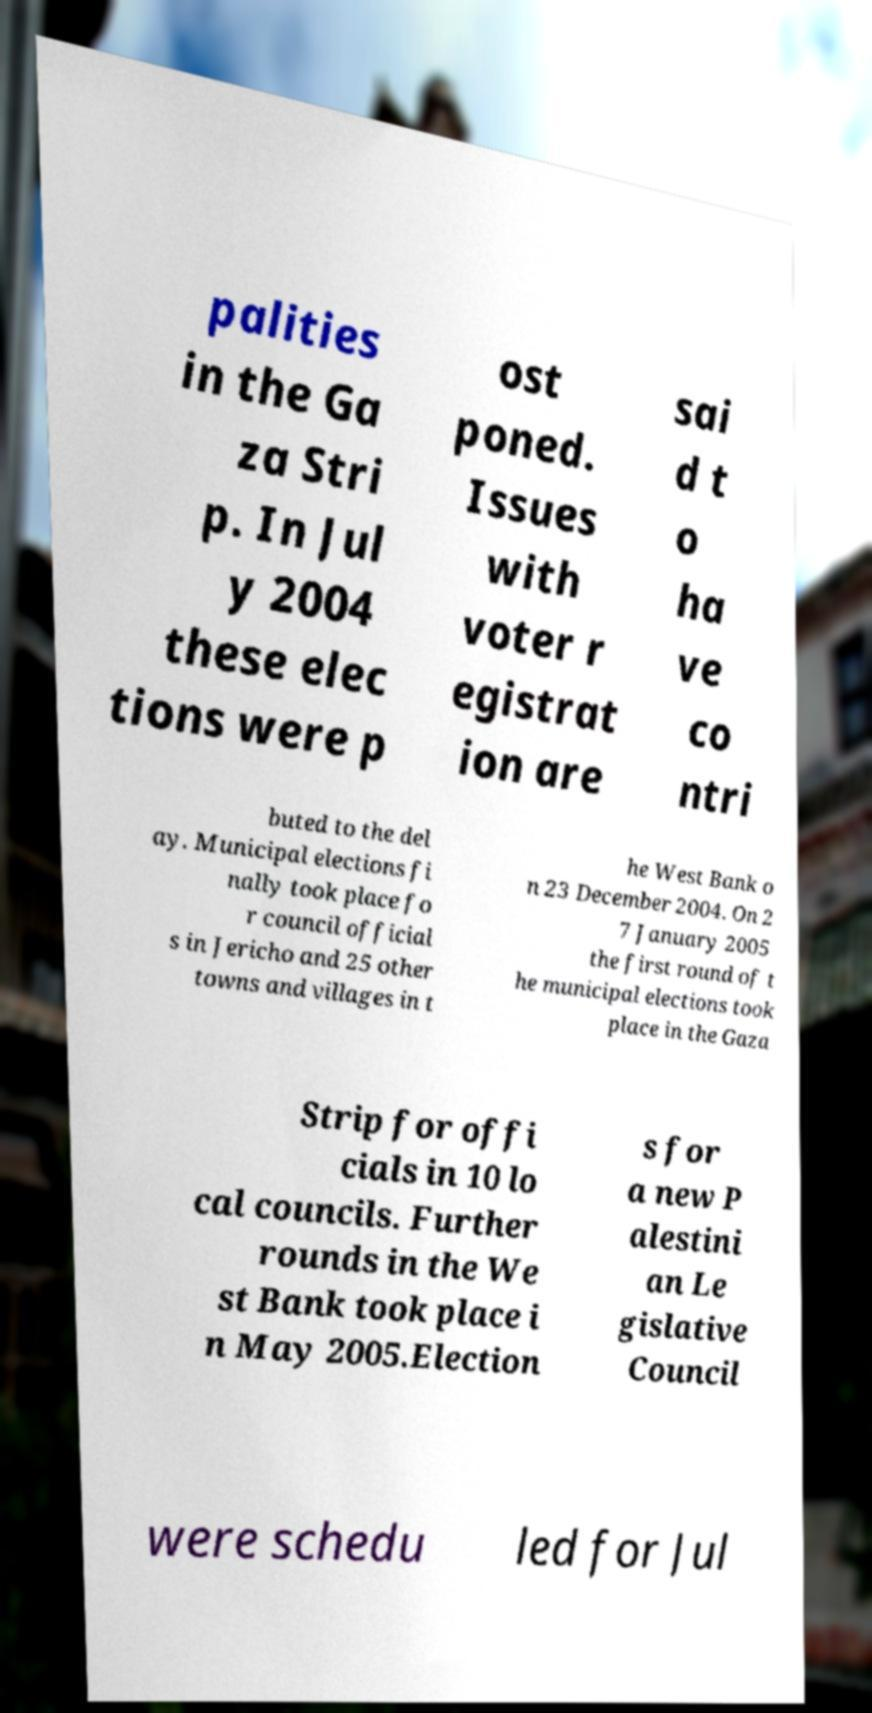There's text embedded in this image that I need extracted. Can you transcribe it verbatim? palities in the Ga za Stri p. In Jul y 2004 these elec tions were p ost poned. Issues with voter r egistrat ion are sai d t o ha ve co ntri buted to the del ay. Municipal elections fi nally took place fo r council official s in Jericho and 25 other towns and villages in t he West Bank o n 23 December 2004. On 2 7 January 2005 the first round of t he municipal elections took place in the Gaza Strip for offi cials in 10 lo cal councils. Further rounds in the We st Bank took place i n May 2005.Election s for a new P alestini an Le gislative Council were schedu led for Jul 